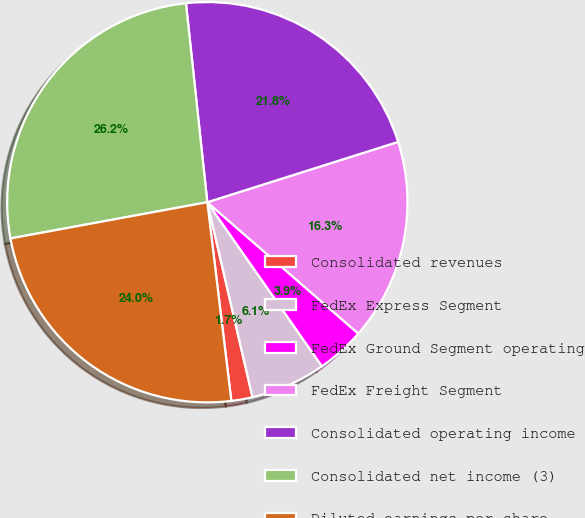<chart> <loc_0><loc_0><loc_500><loc_500><pie_chart><fcel>Consolidated revenues<fcel>FedEx Express Segment<fcel>FedEx Ground Segment operating<fcel>FedEx Freight Segment<fcel>Consolidated operating income<fcel>Consolidated net income (3)<fcel>Diluted earnings per share<nl><fcel>1.71%<fcel>6.08%<fcel>3.9%<fcel>16.27%<fcel>21.83%<fcel>26.2%<fcel>24.02%<nl></chart> 